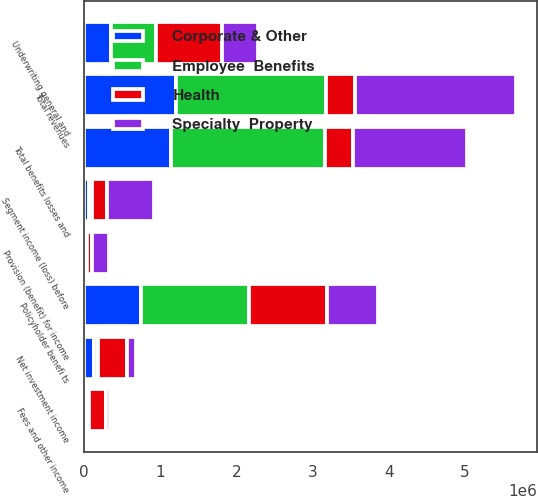Convert chart to OTSL. <chart><loc_0><loc_0><loc_500><loc_500><stacked_bar_chart><ecel><fcel>Net investment income<fcel>Fees and other income<fcel>Total revenues<fcel>Policyholder benefi ts<fcel>Underwriting general and<fcel>Total benefits losses and<fcel>Segment income (loss) before<fcel>Provision (benefit) for income<nl><fcel>Health<fcel>391229<fcel>216550<fcel>372772<fcel>1.02915e+06<fcel>868242<fcel>372772<fcel>194321<fcel>74269<nl><fcel>Specialty  Property<fcel>110337<fcel>56890<fcel>2.11476e+06<fcel>664182<fcel>464865<fcel>1.49671e+06<fcel>618046<fcel>212049<nl><fcel>Employee  Benefits<fcel>47658<fcel>39879<fcel>1.96716e+06<fcel>1.41017e+06<fcel>596172<fcel>2.01487e+06<fcel>47704<fcel>17484<nl><fcel>Corporate & Other<fcel>133365<fcel>28343<fcel>1.21384e+06<fcel>757070<fcel>354316<fcel>1.14997e+06<fcel>63874<fcel>21718<nl></chart> 